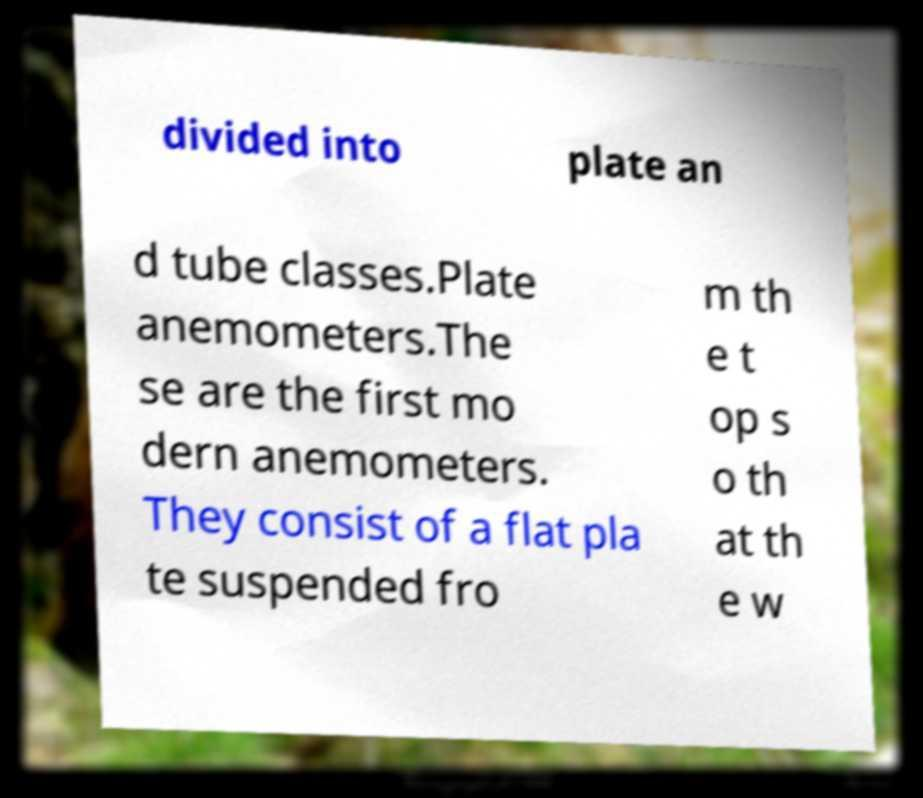For documentation purposes, I need the text within this image transcribed. Could you provide that? divided into plate an d tube classes.Plate anemometers.The se are the first mo dern anemometers. They consist of a flat pla te suspended fro m th e t op s o th at th e w 